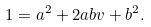<formula> <loc_0><loc_0><loc_500><loc_500>1 = a ^ { 2 } + 2 a b v + b ^ { 2 } .</formula> 